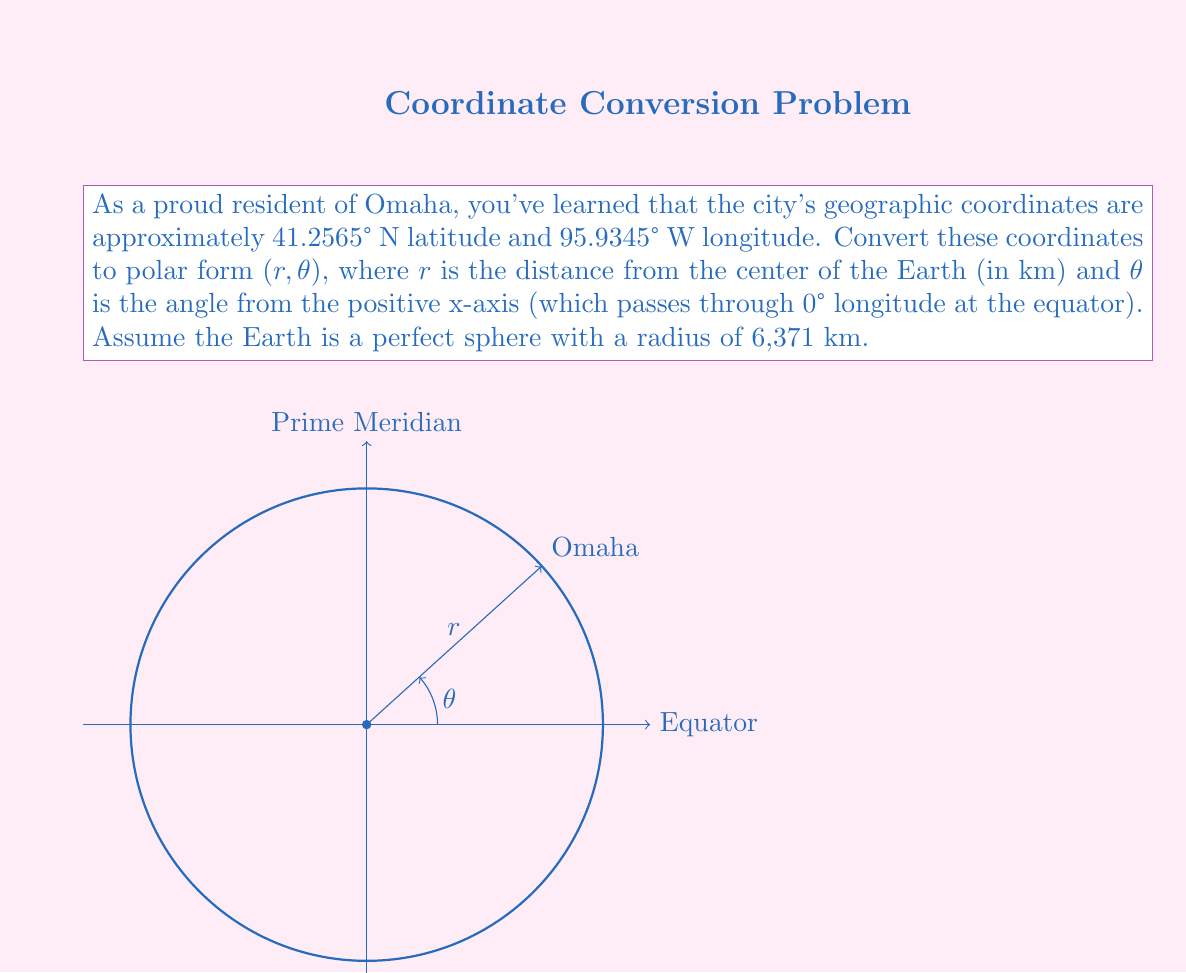Give your solution to this math problem. Let's approach this step-by-step:

1) First, we need to convert the latitude and longitude to radians:
   Latitude: $41.2565° = 41.2565 \times \frac{\pi}{180} = 0.7201$ radians
   Longitude: $-95.9345° = -95.9345 \times \frac{\pi}{180} = -1.6740$ radians (negative because it's west)

2) Now, we can calculate r using the formula:
   $$r = R \sqrt{1 - \sin^2(\text{latitude})}$$
   Where R is the Earth's radius (6,371 km)
   
   $$r = 6371 \sqrt{1 - \sin^2(0.7201)} = 6371 \sqrt{1 - 0.4304} = 6371 \times 0.7549 = 4809.48 \text{ km}$$

3) To find θ, we use the formula:
   $$\theta = \tan^{-1}\left(\frac{\sin(\text{longitude})}{\cos(\text{latitude})\cos(\text{longitude})}\right)$$
   
   $$\theta = \tan^{-1}\left(\frac{\sin(-1.6740)}{\cos(0.7201)\cos(-1.6740)}\right) = \tan^{-1}\left(\frac{-0.9935}{0.7514 \times (-0.1141)}\right)$$
   $$\theta = \tan^{-1}(11.5986) = 1.4849 \text{ radians}$$

4) Convert θ back to degrees:
   $$\theta = 1.4849 \times \frac{180}{\pi} = 85.0776°$$

Therefore, the polar coordinates are (4809.48 km, 85.0776°).
Answer: $(4809.48 \text{ km}, 85.0776°)$ 